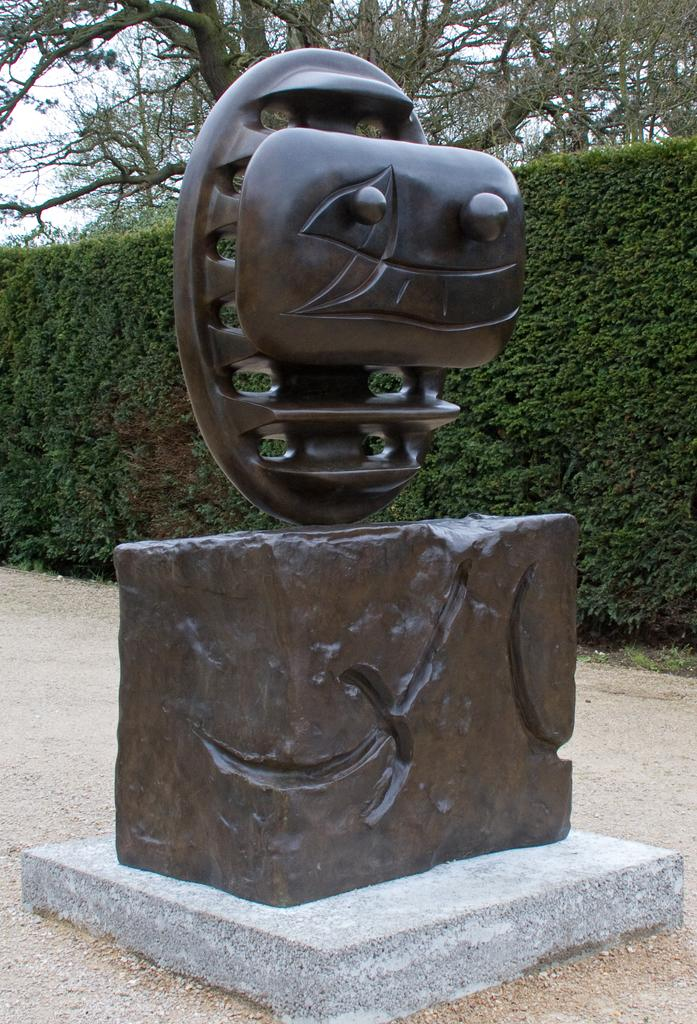What is located on the road in the image? There is a sculpture on the road in the image. What can be seen in the background of the image? There are plants, trees, and the sky visible in the background of the image. Can you describe the time of day when the image was taken? The image was taken during the day. Where is the playground located in the image? There is no playground present in the image. What type of line is visible in the image? There is no specific line mentioned in the provided facts, so it cannot be determined from the image. 